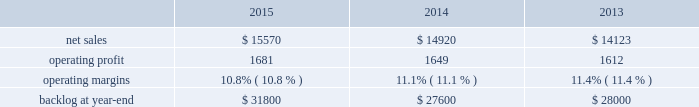Aeronautics our aeronautics business segment is engaged in the research , design , development , manufacture , integration , sustainment , support and upgrade of advanced military aircraft , including combat and air mobility aircraft , unmanned air vehicles and related technologies .
Aeronautics 2019 major programs include the f-35 lightning ii joint strike fighter , c-130 hercules , f-16 fighting falcon , c-5m super galaxy and f-22 raptor .
Aeronautics 2019 operating results included the following ( in millions ) : .
2015 compared to 2014 aeronautics 2019 net sales in 2015 increased $ 650 million , or 4% ( 4 % ) , compared to 2014 .
The increase was attributable to higher net sales of approximately $ 1.4 billion for f-35 production contracts due to increased volume on aircraft production and sustainment activities ; and approximately $ 150 million for the c-5 program due to increased deliveries ( nine aircraft delivered in 2015 compared to seven delivered in 2014 ) .
The increases were partially offset by lower net sales of approximately $ 350 million for the c-130 program due to fewer aircraft deliveries ( 21 aircraft delivered in 2015 , compared to 24 delivered in 2014 ) , lower sustainment activities and aircraft contract mix ; approximately $ 200 million due to decreased volume and lower risk retirements on various programs ; approximately $ 195 million for the f-16 program due to fewer deliveries ( 11 aircraft delivered in 2015 , compared to 17 delivered in 2014 ) ; and approximately $ 190 million for the f-22 program as a result of decreased sustainment activities .
Aeronautics 2019 operating profit in 2015 increased $ 32 million , or 2% ( 2 % ) , compared to 2014 .
Operating profit increased by approximately $ 240 million for f-35 production contracts due to increased volume and risk retirements ; and approximately $ 40 million for the c-5 program due to increased risk retirements .
These increases were offset by lower operating profit of approximately $ 90 million for the f-22 program due to lower risk retirements ; approximately $ 70 million for the c-130 program as a result of the reasons stated above for lower net sales ; and approximately $ 80 million due to decreased volume and risk retirements on various programs .
Adjustments not related to volume , including net profit booking rate adjustments and other matters , were approximately $ 100 million higher in 2015 compared to 2014 .
2014 compared to 2013 aeronautics 2019 net sales increased $ 797 million , or 6% ( 6 % ) , in 2014 as compared to 2013 .
The increase was primarily attributable to higher net sales of approximately $ 790 million for f-35 production contracts due to increased volume and sustainment activities ; about $ 55 million for the f-16 program due to increased deliveries ( 17 aircraft delivered in 2014 compared to 13 delivered in 2013 ) partially offset by contract mix ; and approximately $ 45 million for the f-22 program due to increased risk retirements .
The increases were partially offset by lower net sales of approximately $ 55 million for the f-35 development contract due to decreased volume , partially offset by the absence in 2014 of the downward revision to the profit booking rate that occurred in 2013 ; and about $ 40 million for the c-130 program due to fewer deliveries ( 24 aircraft delivered in 2014 compared to 25 delivered in 2013 ) and decreased sustainment activities , partially offset by contract mix .
Aeronautics 2019 operating profit increased $ 37 million , or 2% ( 2 % ) , in 2014 as compared to 2013 .
The increase was primarily attributable to higher operating profit of approximately $ 85 million for the f-35 development contract due to the absence in 2014 of the downward revision to the profit booking rate that occurred in 2013 ; about $ 75 million for the f-22 program due to increased risk retirements ; approximately $ 50 million for the c-130 program due to increased risk retirements and contract mix , partially offset by fewer deliveries ; and about $ 25 million for the c-5 program due to the absence in 2014 of the downward revisions to the profit booking rate that occurred in 2013 .
The increases were partially offset by lower operating profit of approximately $ 130 million for the f-16 program due to decreased risk retirements , partially offset by increased deliveries ; and about $ 70 million for sustainment activities due to decreased risk retirements and volume .
Operating profit was comparable for f-35 production contracts as higher volume was offset by lower risk retirements .
Adjustments not related to volume , including net profit booking rate adjustments and other matters , were approximately $ 105 million lower for 2014 compared to 2013. .
What was the average operating margin from 2013 to 2015? 
Computations: table_average(operating margins, none)
Answer: 0.111. Aeronautics our aeronautics business segment is engaged in the research , design , development , manufacture , integration , sustainment , support and upgrade of advanced military aircraft , including combat and air mobility aircraft , unmanned air vehicles and related technologies .
Aeronautics 2019 major programs include the f-35 lightning ii joint strike fighter , c-130 hercules , f-16 fighting falcon , c-5m super galaxy and f-22 raptor .
Aeronautics 2019 operating results included the following ( in millions ) : .
2015 compared to 2014 aeronautics 2019 net sales in 2015 increased $ 650 million , or 4% ( 4 % ) , compared to 2014 .
The increase was attributable to higher net sales of approximately $ 1.4 billion for f-35 production contracts due to increased volume on aircraft production and sustainment activities ; and approximately $ 150 million for the c-5 program due to increased deliveries ( nine aircraft delivered in 2015 compared to seven delivered in 2014 ) .
The increases were partially offset by lower net sales of approximately $ 350 million for the c-130 program due to fewer aircraft deliveries ( 21 aircraft delivered in 2015 , compared to 24 delivered in 2014 ) , lower sustainment activities and aircraft contract mix ; approximately $ 200 million due to decreased volume and lower risk retirements on various programs ; approximately $ 195 million for the f-16 program due to fewer deliveries ( 11 aircraft delivered in 2015 , compared to 17 delivered in 2014 ) ; and approximately $ 190 million for the f-22 program as a result of decreased sustainment activities .
Aeronautics 2019 operating profit in 2015 increased $ 32 million , or 2% ( 2 % ) , compared to 2014 .
Operating profit increased by approximately $ 240 million for f-35 production contracts due to increased volume and risk retirements ; and approximately $ 40 million for the c-5 program due to increased risk retirements .
These increases were offset by lower operating profit of approximately $ 90 million for the f-22 program due to lower risk retirements ; approximately $ 70 million for the c-130 program as a result of the reasons stated above for lower net sales ; and approximately $ 80 million due to decreased volume and risk retirements on various programs .
Adjustments not related to volume , including net profit booking rate adjustments and other matters , were approximately $ 100 million higher in 2015 compared to 2014 .
2014 compared to 2013 aeronautics 2019 net sales increased $ 797 million , or 6% ( 6 % ) , in 2014 as compared to 2013 .
The increase was primarily attributable to higher net sales of approximately $ 790 million for f-35 production contracts due to increased volume and sustainment activities ; about $ 55 million for the f-16 program due to increased deliveries ( 17 aircraft delivered in 2014 compared to 13 delivered in 2013 ) partially offset by contract mix ; and approximately $ 45 million for the f-22 program due to increased risk retirements .
The increases were partially offset by lower net sales of approximately $ 55 million for the f-35 development contract due to decreased volume , partially offset by the absence in 2014 of the downward revision to the profit booking rate that occurred in 2013 ; and about $ 40 million for the c-130 program due to fewer deliveries ( 24 aircraft delivered in 2014 compared to 25 delivered in 2013 ) and decreased sustainment activities , partially offset by contract mix .
Aeronautics 2019 operating profit increased $ 37 million , or 2% ( 2 % ) , in 2014 as compared to 2013 .
The increase was primarily attributable to higher operating profit of approximately $ 85 million for the f-35 development contract due to the absence in 2014 of the downward revision to the profit booking rate that occurred in 2013 ; about $ 75 million for the f-22 program due to increased risk retirements ; approximately $ 50 million for the c-130 program due to increased risk retirements and contract mix , partially offset by fewer deliveries ; and about $ 25 million for the c-5 program due to the absence in 2014 of the downward revisions to the profit booking rate that occurred in 2013 .
The increases were partially offset by lower operating profit of approximately $ 130 million for the f-16 program due to decreased risk retirements , partially offset by increased deliveries ; and about $ 70 million for sustainment activities due to decreased risk retirements and volume .
Operating profit was comparable for f-35 production contracts as higher volume was offset by lower risk retirements .
Adjustments not related to volume , including net profit booking rate adjustments and other matters , were approximately $ 105 million lower for 2014 compared to 2013. .
What was the average aeronautics 2019 operating profit from 2013 to 2015? 
Computations: (((1681 + 1649) + 1612) / 3)
Answer: 1647.33333. 